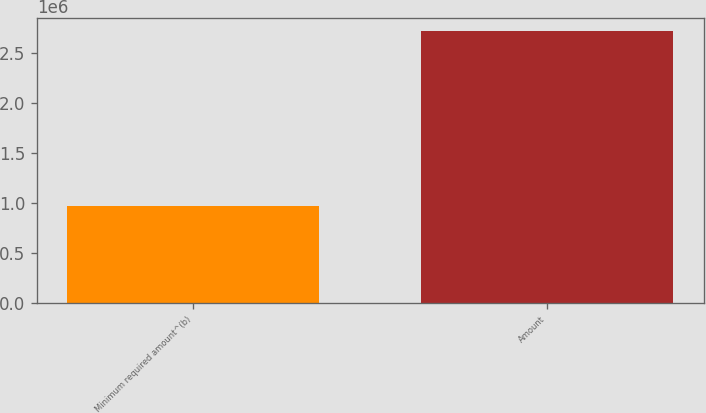<chart> <loc_0><loc_0><loc_500><loc_500><bar_chart><fcel>Minimum required amount^(b)<fcel>Amount<nl><fcel>972521<fcel>2.72014e+06<nl></chart> 